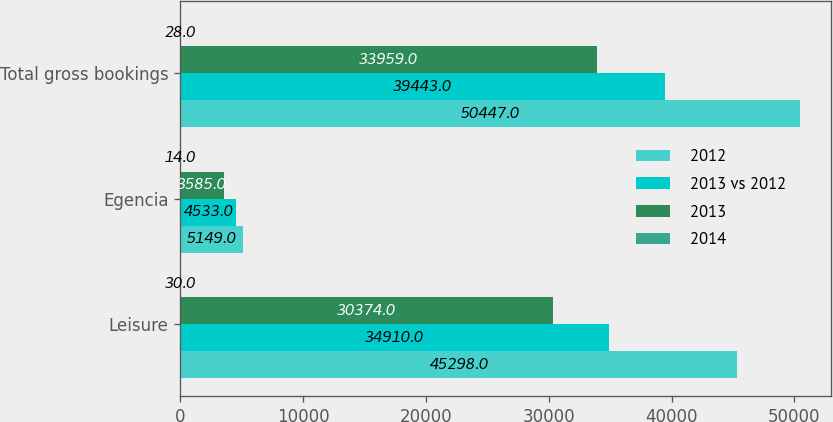Convert chart. <chart><loc_0><loc_0><loc_500><loc_500><stacked_bar_chart><ecel><fcel>Leisure<fcel>Egencia<fcel>Total gross bookings<nl><fcel>2012<fcel>45298<fcel>5149<fcel>50447<nl><fcel>2013 vs 2012<fcel>34910<fcel>4533<fcel>39443<nl><fcel>2013<fcel>30374<fcel>3585<fcel>33959<nl><fcel>2014<fcel>30<fcel>14<fcel>28<nl></chart> 